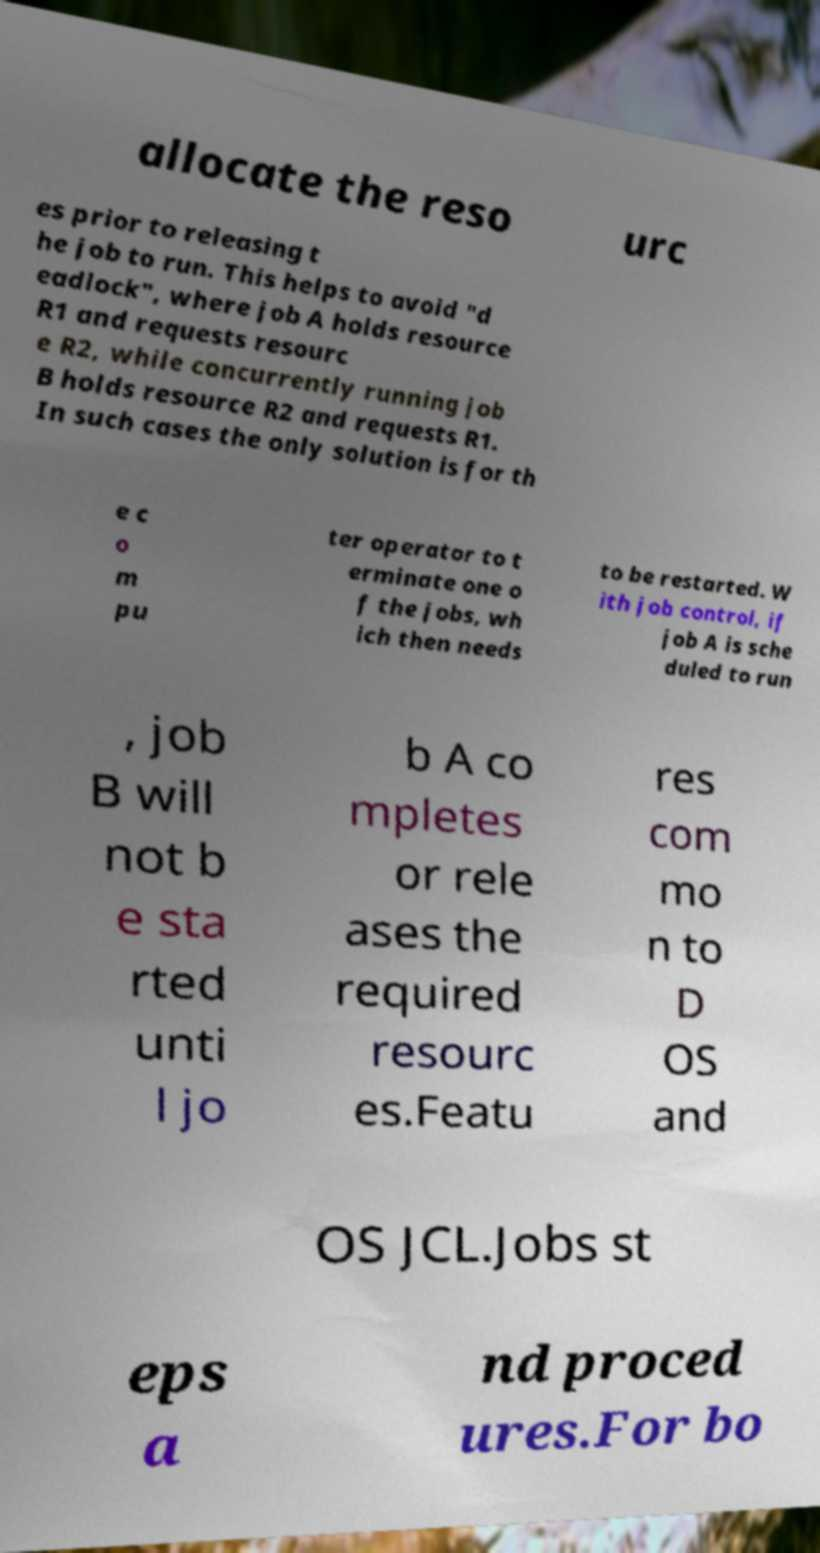Please read and relay the text visible in this image. What does it say? allocate the reso urc es prior to releasing t he job to run. This helps to avoid "d eadlock", where job A holds resource R1 and requests resourc e R2, while concurrently running job B holds resource R2 and requests R1. In such cases the only solution is for th e c o m pu ter operator to t erminate one o f the jobs, wh ich then needs to be restarted. W ith job control, if job A is sche duled to run , job B will not b e sta rted unti l jo b A co mpletes or rele ases the required resourc es.Featu res com mo n to D OS and OS JCL.Jobs st eps a nd proced ures.For bo 